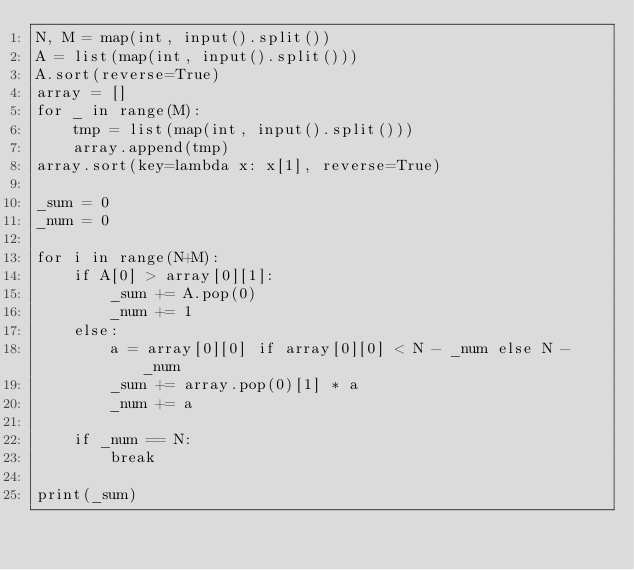<code> <loc_0><loc_0><loc_500><loc_500><_Python_>N, M = map(int, input().split())
A = list(map(int, input().split()))
A.sort(reverse=True)
array = []
for _ in range(M):
    tmp = list(map(int, input().split()))
    array.append(tmp)
array.sort(key=lambda x: x[1], reverse=True)

_sum = 0
_num = 0

for i in range(N+M):
    if A[0] > array[0][1]:
        _sum += A.pop(0)
        _num += 1
    else:
        a = array[0][0] if array[0][0] < N - _num else N - _num
        _sum += array.pop(0)[1] * a
        _num += a
        
    if _num == N:
        break
    
print(_sum)</code> 